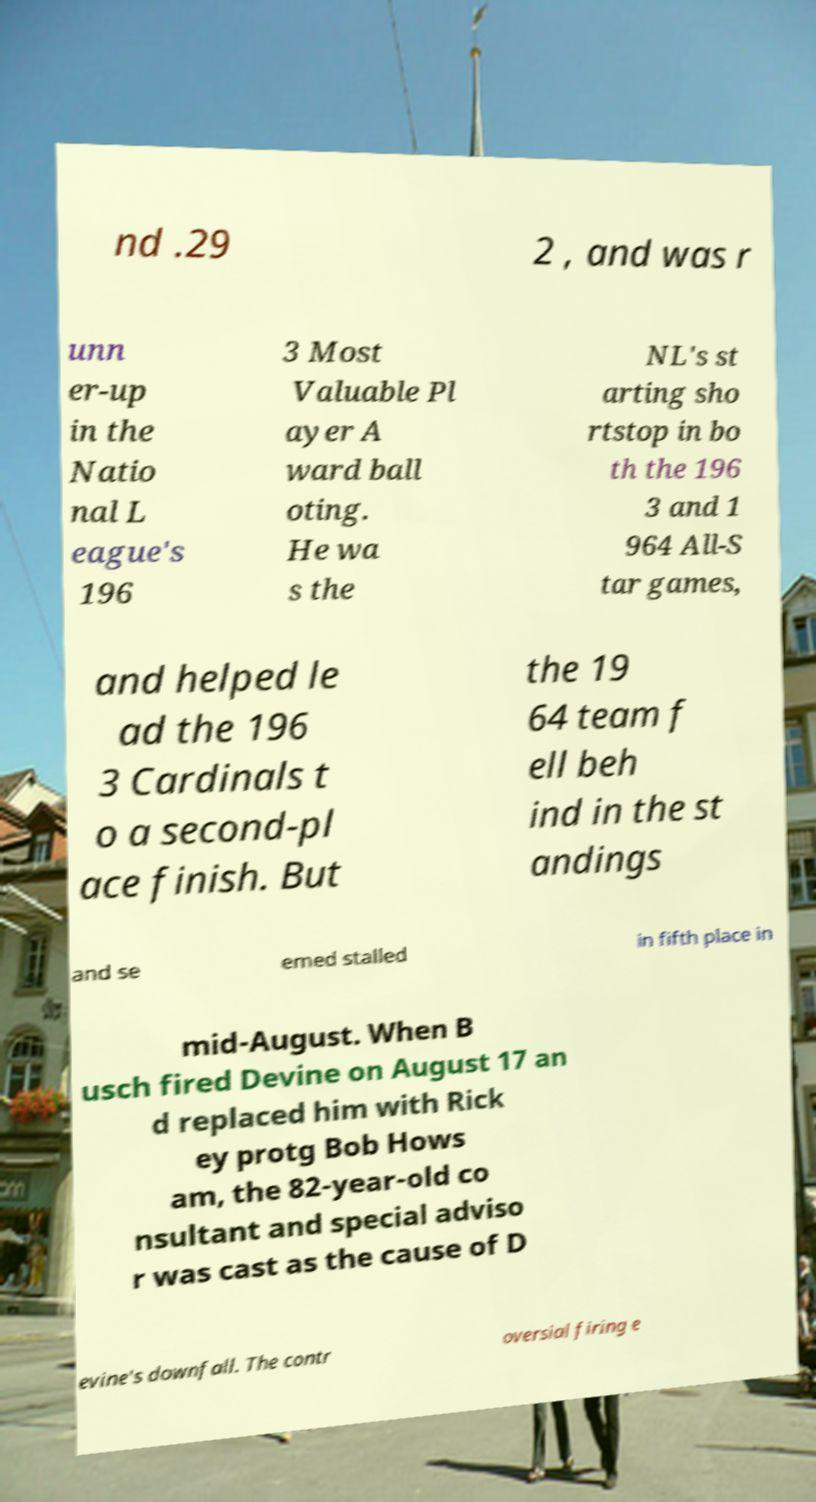Could you assist in decoding the text presented in this image and type it out clearly? nd .29 2 , and was r unn er-up in the Natio nal L eague's 196 3 Most Valuable Pl ayer A ward ball oting. He wa s the NL's st arting sho rtstop in bo th the 196 3 and 1 964 All-S tar games, and helped le ad the 196 3 Cardinals t o a second-pl ace finish. But the 19 64 team f ell beh ind in the st andings and se emed stalled in fifth place in mid-August. When B usch fired Devine on August 17 an d replaced him with Rick ey protg Bob Hows am, the 82-year-old co nsultant and special adviso r was cast as the cause of D evine's downfall. The contr oversial firing e 